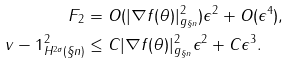Convert formula to latex. <formula><loc_0><loc_0><loc_500><loc_500>F _ { 2 } & = O ( | \nabla f ( \theta ) | _ { g _ { \S n } } ^ { 2 } ) \epsilon ^ { 2 } + O ( \epsilon ^ { 4 } ) , \\ \| v - 1 \| _ { H ^ { 2 \sigma } ( \S n ) } ^ { 2 } & \leq C | \nabla f ( \theta ) | _ { g _ { \S n } } ^ { 2 } \epsilon ^ { 2 } + C \epsilon ^ { 3 } .</formula> 